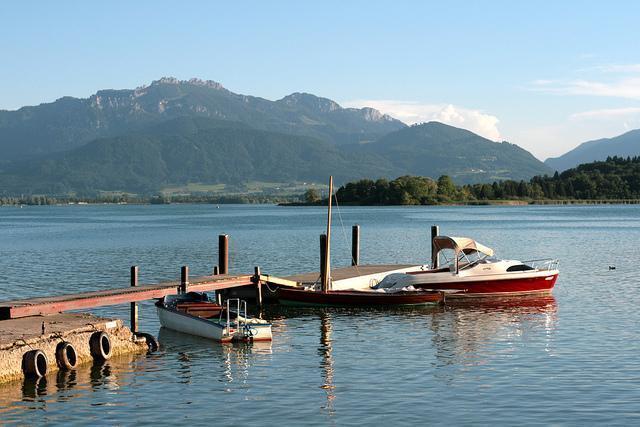What is the name of the platform used to walk out on the water?
Choose the correct response, then elucidate: 'Answer: answer
Rationale: rationale.'
Options: Tub, plank, pier, steps. Answer: pier.
Rationale: It is a platform extending from the shore over the water and supported by pillars that is used to secure, protect, and provide access to ships or boats. 